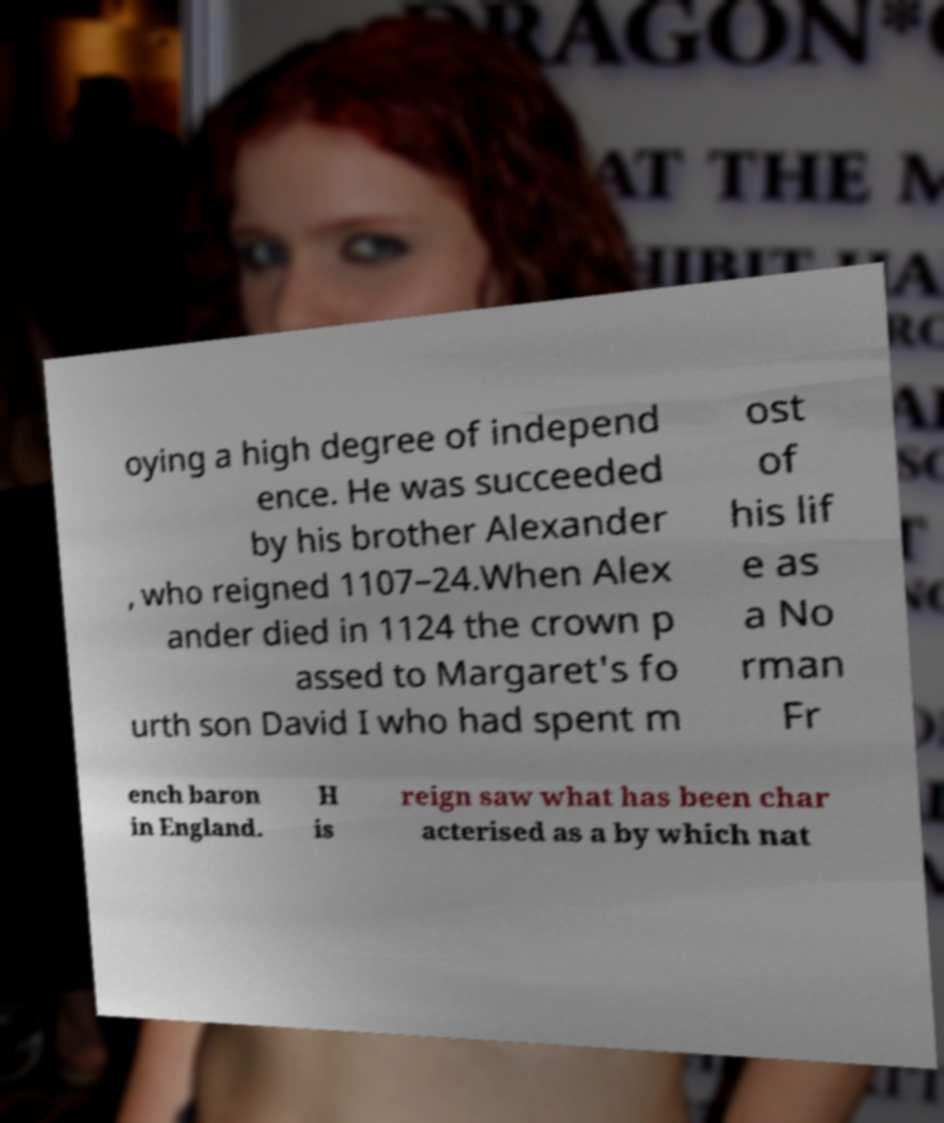What messages or text are displayed in this image? I need them in a readable, typed format. oying a high degree of independ ence. He was succeeded by his brother Alexander , who reigned 1107–24.When Alex ander died in 1124 the crown p assed to Margaret's fo urth son David I who had spent m ost of his lif e as a No rman Fr ench baron in England. H is reign saw what has been char acterised as a by which nat 